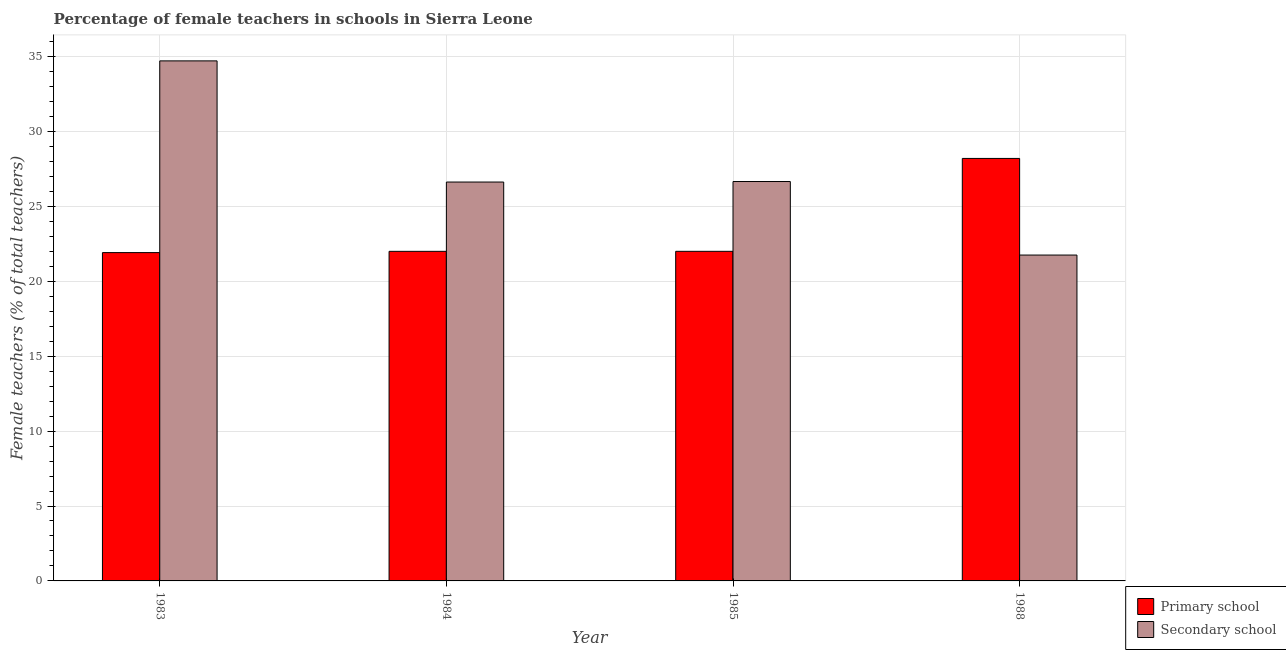How many different coloured bars are there?
Provide a succinct answer. 2. Are the number of bars per tick equal to the number of legend labels?
Keep it short and to the point. Yes. What is the label of the 3rd group of bars from the left?
Offer a terse response. 1985. What is the percentage of female teachers in primary schools in 1988?
Your answer should be compact. 28.2. Across all years, what is the maximum percentage of female teachers in secondary schools?
Ensure brevity in your answer.  34.71. Across all years, what is the minimum percentage of female teachers in secondary schools?
Ensure brevity in your answer.  21.75. What is the total percentage of female teachers in secondary schools in the graph?
Provide a short and direct response. 109.73. What is the difference between the percentage of female teachers in secondary schools in 1983 and that in 1988?
Offer a terse response. 12.96. What is the difference between the percentage of female teachers in secondary schools in 1988 and the percentage of female teachers in primary schools in 1984?
Give a very brief answer. -4.87. What is the average percentage of female teachers in secondary schools per year?
Offer a terse response. 27.43. In how many years, is the percentage of female teachers in secondary schools greater than 8 %?
Your answer should be very brief. 4. What is the ratio of the percentage of female teachers in primary schools in 1984 to that in 1988?
Your answer should be very brief. 0.78. What is the difference between the highest and the second highest percentage of female teachers in primary schools?
Offer a very short reply. 6.2. What is the difference between the highest and the lowest percentage of female teachers in secondary schools?
Your answer should be very brief. 12.96. In how many years, is the percentage of female teachers in primary schools greater than the average percentage of female teachers in primary schools taken over all years?
Your response must be concise. 1. What does the 2nd bar from the left in 1985 represents?
Ensure brevity in your answer.  Secondary school. What does the 1st bar from the right in 1984 represents?
Give a very brief answer. Secondary school. How many bars are there?
Offer a very short reply. 8. What is the difference between two consecutive major ticks on the Y-axis?
Provide a succinct answer. 5. Are the values on the major ticks of Y-axis written in scientific E-notation?
Offer a terse response. No. Does the graph contain any zero values?
Ensure brevity in your answer.  No. Does the graph contain grids?
Give a very brief answer. Yes. Where does the legend appear in the graph?
Your response must be concise. Bottom right. How are the legend labels stacked?
Your response must be concise. Vertical. What is the title of the graph?
Offer a very short reply. Percentage of female teachers in schools in Sierra Leone. What is the label or title of the Y-axis?
Provide a short and direct response. Female teachers (% of total teachers). What is the Female teachers (% of total teachers) in Primary school in 1983?
Your answer should be very brief. 21.91. What is the Female teachers (% of total teachers) in Secondary school in 1983?
Offer a very short reply. 34.71. What is the Female teachers (% of total teachers) of Primary school in 1984?
Provide a succinct answer. 22. What is the Female teachers (% of total teachers) in Secondary school in 1984?
Ensure brevity in your answer.  26.62. What is the Female teachers (% of total teachers) in Primary school in 1985?
Provide a short and direct response. 22. What is the Female teachers (% of total teachers) of Secondary school in 1985?
Offer a very short reply. 26.65. What is the Female teachers (% of total teachers) in Primary school in 1988?
Offer a very short reply. 28.2. What is the Female teachers (% of total teachers) of Secondary school in 1988?
Ensure brevity in your answer.  21.75. Across all years, what is the maximum Female teachers (% of total teachers) in Primary school?
Offer a very short reply. 28.2. Across all years, what is the maximum Female teachers (% of total teachers) of Secondary school?
Ensure brevity in your answer.  34.71. Across all years, what is the minimum Female teachers (% of total teachers) of Primary school?
Your answer should be compact. 21.91. Across all years, what is the minimum Female teachers (% of total teachers) of Secondary school?
Offer a very short reply. 21.75. What is the total Female teachers (% of total teachers) in Primary school in the graph?
Ensure brevity in your answer.  94.1. What is the total Female teachers (% of total teachers) in Secondary school in the graph?
Offer a very short reply. 109.73. What is the difference between the Female teachers (% of total teachers) in Primary school in 1983 and that in 1984?
Your response must be concise. -0.08. What is the difference between the Female teachers (% of total teachers) in Secondary school in 1983 and that in 1984?
Your response must be concise. 8.09. What is the difference between the Female teachers (% of total teachers) in Primary school in 1983 and that in 1985?
Ensure brevity in your answer.  -0.09. What is the difference between the Female teachers (% of total teachers) of Secondary school in 1983 and that in 1985?
Make the answer very short. 8.05. What is the difference between the Female teachers (% of total teachers) of Primary school in 1983 and that in 1988?
Provide a short and direct response. -6.28. What is the difference between the Female teachers (% of total teachers) in Secondary school in 1983 and that in 1988?
Ensure brevity in your answer.  12.96. What is the difference between the Female teachers (% of total teachers) in Primary school in 1984 and that in 1985?
Provide a short and direct response. -0. What is the difference between the Female teachers (% of total teachers) of Secondary school in 1984 and that in 1985?
Provide a succinct answer. -0.03. What is the difference between the Female teachers (% of total teachers) in Primary school in 1984 and that in 1988?
Provide a succinct answer. -6.2. What is the difference between the Female teachers (% of total teachers) in Secondary school in 1984 and that in 1988?
Provide a succinct answer. 4.87. What is the difference between the Female teachers (% of total teachers) in Primary school in 1985 and that in 1988?
Your answer should be compact. -6.2. What is the difference between the Female teachers (% of total teachers) of Secondary school in 1985 and that in 1988?
Keep it short and to the point. 4.91. What is the difference between the Female teachers (% of total teachers) of Primary school in 1983 and the Female teachers (% of total teachers) of Secondary school in 1984?
Give a very brief answer. -4.71. What is the difference between the Female teachers (% of total teachers) of Primary school in 1983 and the Female teachers (% of total teachers) of Secondary school in 1985?
Your response must be concise. -4.74. What is the difference between the Female teachers (% of total teachers) of Primary school in 1983 and the Female teachers (% of total teachers) of Secondary school in 1988?
Offer a terse response. 0.16. What is the difference between the Female teachers (% of total teachers) of Primary school in 1984 and the Female teachers (% of total teachers) of Secondary school in 1985?
Ensure brevity in your answer.  -4.66. What is the difference between the Female teachers (% of total teachers) in Primary school in 1984 and the Female teachers (% of total teachers) in Secondary school in 1988?
Offer a terse response. 0.25. What is the difference between the Female teachers (% of total teachers) in Primary school in 1985 and the Female teachers (% of total teachers) in Secondary school in 1988?
Offer a very short reply. 0.25. What is the average Female teachers (% of total teachers) in Primary school per year?
Offer a terse response. 23.53. What is the average Female teachers (% of total teachers) of Secondary school per year?
Your response must be concise. 27.43. In the year 1983, what is the difference between the Female teachers (% of total teachers) in Primary school and Female teachers (% of total teachers) in Secondary school?
Offer a terse response. -12.8. In the year 1984, what is the difference between the Female teachers (% of total teachers) in Primary school and Female teachers (% of total teachers) in Secondary school?
Your answer should be compact. -4.63. In the year 1985, what is the difference between the Female teachers (% of total teachers) in Primary school and Female teachers (% of total teachers) in Secondary school?
Ensure brevity in your answer.  -4.66. In the year 1988, what is the difference between the Female teachers (% of total teachers) of Primary school and Female teachers (% of total teachers) of Secondary school?
Offer a terse response. 6.45. What is the ratio of the Female teachers (% of total teachers) of Primary school in 1983 to that in 1984?
Keep it short and to the point. 1. What is the ratio of the Female teachers (% of total teachers) of Secondary school in 1983 to that in 1984?
Offer a terse response. 1.3. What is the ratio of the Female teachers (% of total teachers) of Secondary school in 1983 to that in 1985?
Make the answer very short. 1.3. What is the ratio of the Female teachers (% of total teachers) in Primary school in 1983 to that in 1988?
Your answer should be compact. 0.78. What is the ratio of the Female teachers (% of total teachers) of Secondary school in 1983 to that in 1988?
Make the answer very short. 1.6. What is the ratio of the Female teachers (% of total teachers) in Primary school in 1984 to that in 1985?
Provide a short and direct response. 1. What is the ratio of the Female teachers (% of total teachers) in Primary school in 1984 to that in 1988?
Offer a terse response. 0.78. What is the ratio of the Female teachers (% of total teachers) in Secondary school in 1984 to that in 1988?
Your response must be concise. 1.22. What is the ratio of the Female teachers (% of total teachers) in Primary school in 1985 to that in 1988?
Your response must be concise. 0.78. What is the ratio of the Female teachers (% of total teachers) of Secondary school in 1985 to that in 1988?
Your response must be concise. 1.23. What is the difference between the highest and the second highest Female teachers (% of total teachers) in Primary school?
Provide a succinct answer. 6.2. What is the difference between the highest and the second highest Female teachers (% of total teachers) of Secondary school?
Your answer should be very brief. 8.05. What is the difference between the highest and the lowest Female teachers (% of total teachers) of Primary school?
Your answer should be very brief. 6.28. What is the difference between the highest and the lowest Female teachers (% of total teachers) of Secondary school?
Your answer should be compact. 12.96. 